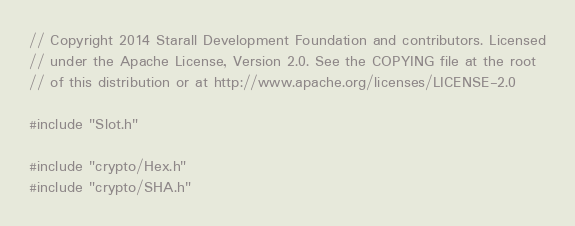Convert code to text. <code><loc_0><loc_0><loc_500><loc_500><_C++_>// Copyright 2014 Starall Development Foundation and contributors. Licensed
// under the Apache License, Version 2.0. See the COPYING file at the root
// of this distribution or at http://www.apache.org/licenses/LICENSE-2.0

#include "Slot.h"

#include "crypto/Hex.h"
#include "crypto/SHA.h"</code> 